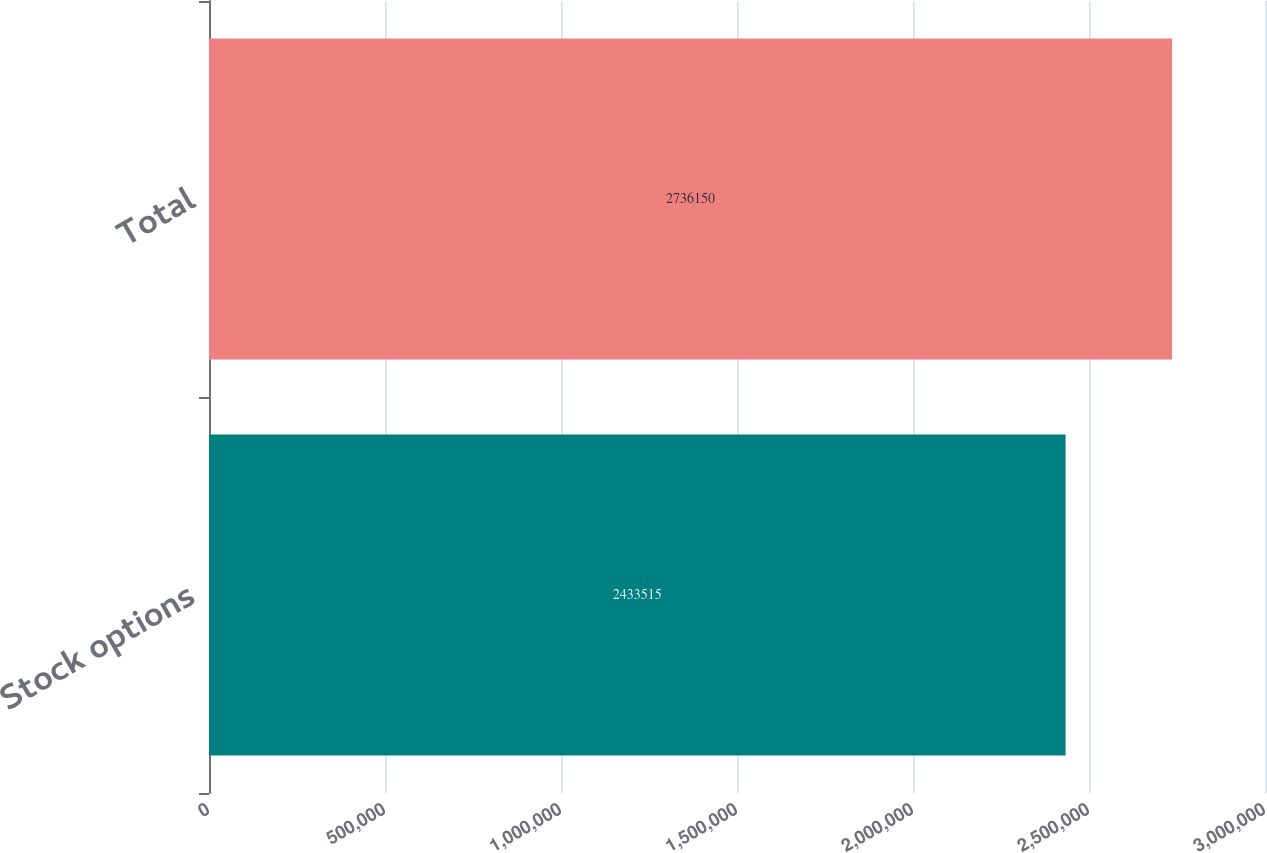<chart> <loc_0><loc_0><loc_500><loc_500><bar_chart><fcel>Stock options<fcel>Total<nl><fcel>2.43352e+06<fcel>2.73615e+06<nl></chart> 